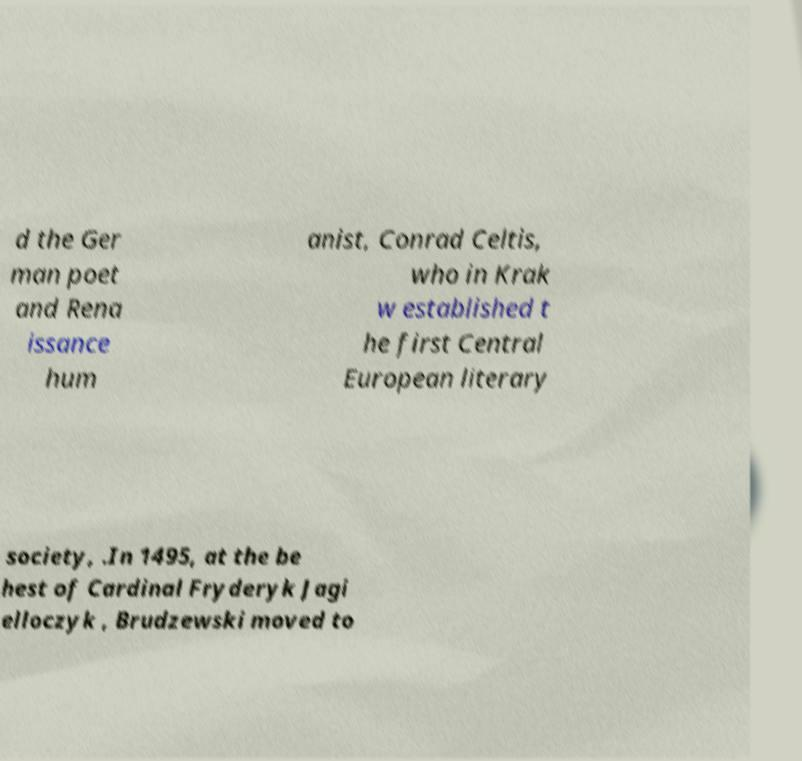Can you read and provide the text displayed in the image?This photo seems to have some interesting text. Can you extract and type it out for me? d the Ger man poet and Rena issance hum anist, Conrad Celtis, who in Krak w established t he first Central European literary society, .In 1495, at the be hest of Cardinal Fryderyk Jagi elloczyk , Brudzewski moved to 